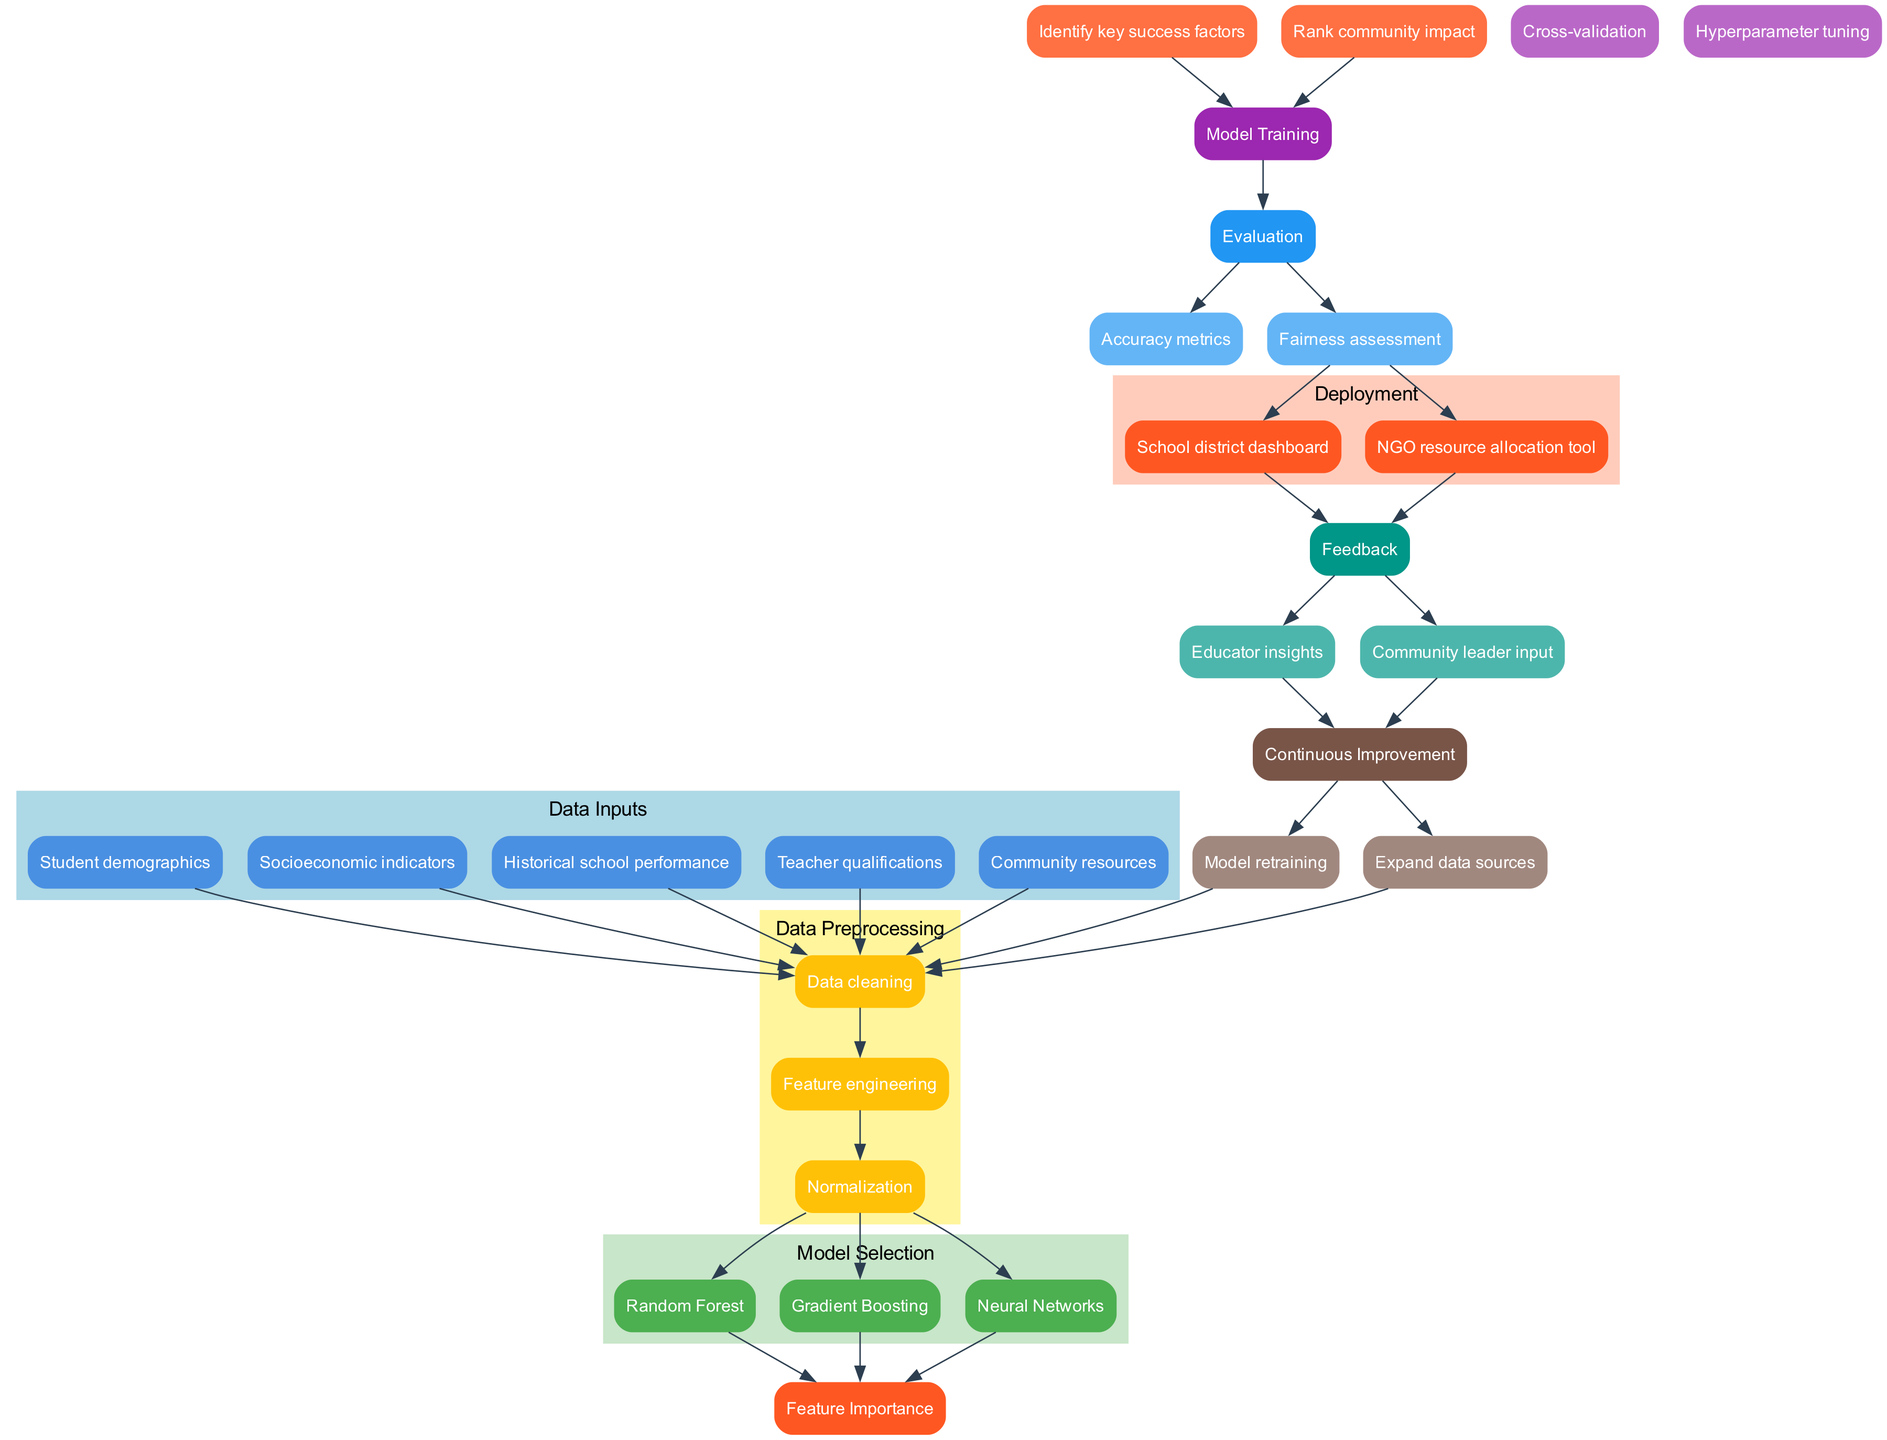What are the data inputs in the diagram? The data inputs are listed in a cluster labeled "Data Inputs." They include various categories that influence student success, such as demographics, socioeconomic indicators, historical performance, teacher qualifications, and community resources.
Answer: Student demographics, socioeconomic indicators, historical school performance, teacher qualifications, community resources How many nodes are there in the "Model Selection" section? The "Model Selection" section contains three nodes, representing the different algorithms chosen for prediction—Random Forest, Gradient Boosting, and Neural Networks.
Answer: Three What is the first step in the data preprocessing stage? The first step in the "Data Preprocessing" stage is "Data cleaning," which is essential to ensure the quality of the data before further processing steps.
Answer: Data cleaning Which node is connected to "Feature Importance"? The node "Feature Importance" is connected to all nodes in the "Model Selection" section, indicating that after selecting a model, understanding feature importance is the next step.
Answer: Model Selection What does the "Continuous Improvement" phase lead back to? The "Continuous Improvement" phase leads back to the "Data Preprocessing" node, indicating that insights gained from feedback are used to enhance the preprocessing step continuously.
Answer: Data Preprocessing Which evaluation metrics are listed in the "Evaluation" stage? The "Evaluation" stage includes nodes for "Accuracy metrics" and "Fairness assessment," highlighting the importance of both performance and equity in evaluating the model.
Answer: Accuracy metrics, Fairness assessment What does the "Deployment" section consist of? The "Deployment" section consists of a school district dashboard and an NGO resource allocation tool, both designed to facilitate the real-world application of the predictions.
Answer: School district dashboard, NGO resource allocation tool What connects "Model Training" to "Evaluation"? The "Model Training" node is directly connected to the "Evaluation" node, indicating that after training the model, it is evaluated to assess its performance.
Answer: Evaluation Which node receives input from "Feature Importance"? The node "Model Training" receives input from "Feature Importance," signifying that the understanding of feature importance feeds into the training process of the machine learning model.
Answer: Model Training 